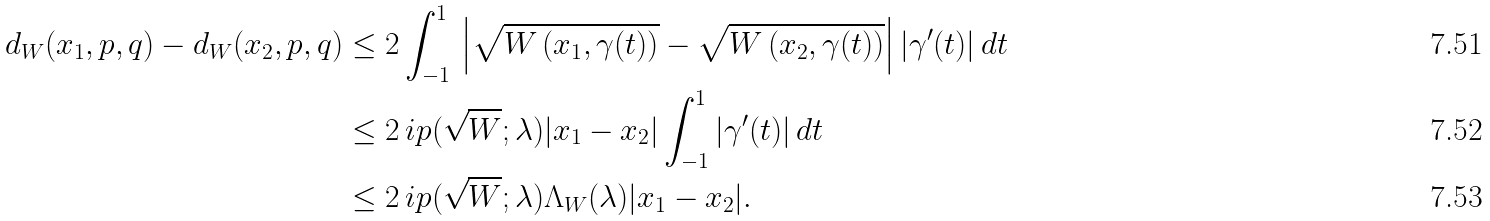Convert formula to latex. <formula><loc_0><loc_0><loc_500><loc_500>d _ { W } ( x _ { 1 } , p , q ) - d _ { W } ( x _ { 2 } , p , q ) & \leq 2 \int _ { - 1 } ^ { 1 } \, \left | \sqrt { W \left ( x _ { 1 } , \gamma ( t ) \right ) } - \sqrt { W \left ( x _ { 2 } , \gamma ( t ) \right ) } \right | | \gamma ^ { \prime } ( t ) | \, d t \\ & \leq 2 \, \L i p ( \sqrt { W } ; \lambda ) | x _ { 1 } - x _ { 2 } | \int _ { - 1 } ^ { 1 } | \gamma ^ { \prime } ( t ) | \, d t \\ & \leq 2 \, \L i p ( \sqrt { W } ; \lambda ) \Lambda _ { W } ( \lambda ) | x _ { 1 } - x _ { 2 } | .</formula> 